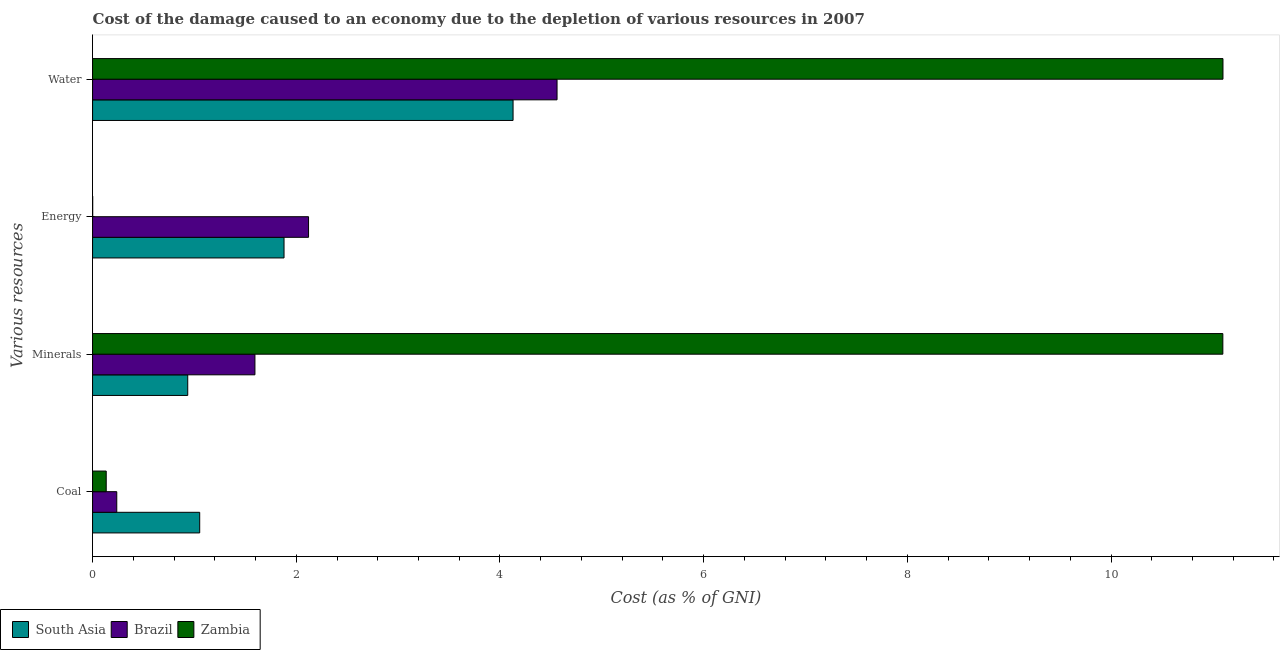What is the label of the 3rd group of bars from the top?
Keep it short and to the point. Minerals. What is the cost of damage due to depletion of coal in South Asia?
Offer a terse response. 1.05. Across all countries, what is the maximum cost of damage due to depletion of energy?
Provide a short and direct response. 2.12. Across all countries, what is the minimum cost of damage due to depletion of water?
Your answer should be very brief. 4.13. In which country was the cost of damage due to depletion of minerals maximum?
Give a very brief answer. Zambia. What is the total cost of damage due to depletion of water in the graph?
Offer a very short reply. 19.79. What is the difference between the cost of damage due to depletion of water in South Asia and that in Zambia?
Offer a terse response. -6.97. What is the difference between the cost of damage due to depletion of coal in Brazil and the cost of damage due to depletion of minerals in Zambia?
Keep it short and to the point. -10.86. What is the average cost of damage due to depletion of coal per country?
Ensure brevity in your answer.  0.47. What is the difference between the cost of damage due to depletion of energy and cost of damage due to depletion of coal in Zambia?
Provide a succinct answer. -0.13. What is the ratio of the cost of damage due to depletion of energy in Zambia to that in South Asia?
Give a very brief answer. 0. What is the difference between the highest and the second highest cost of damage due to depletion of energy?
Offer a very short reply. 0.24. What is the difference between the highest and the lowest cost of damage due to depletion of coal?
Make the answer very short. 0.92. Is it the case that in every country, the sum of the cost of damage due to depletion of water and cost of damage due to depletion of minerals is greater than the sum of cost of damage due to depletion of coal and cost of damage due to depletion of energy?
Offer a very short reply. Yes. What does the 1st bar from the top in Energy represents?
Your answer should be compact. Zambia. Is it the case that in every country, the sum of the cost of damage due to depletion of coal and cost of damage due to depletion of minerals is greater than the cost of damage due to depletion of energy?
Your answer should be very brief. No. What is the difference between two consecutive major ticks on the X-axis?
Provide a succinct answer. 2. Are the values on the major ticks of X-axis written in scientific E-notation?
Your response must be concise. No. Does the graph contain grids?
Make the answer very short. No. Where does the legend appear in the graph?
Ensure brevity in your answer.  Bottom left. How many legend labels are there?
Offer a terse response. 3. What is the title of the graph?
Offer a very short reply. Cost of the damage caused to an economy due to the depletion of various resources in 2007 . Does "Costa Rica" appear as one of the legend labels in the graph?
Make the answer very short. No. What is the label or title of the X-axis?
Keep it short and to the point. Cost (as % of GNI). What is the label or title of the Y-axis?
Offer a terse response. Various resources. What is the Cost (as % of GNI) in South Asia in Coal?
Make the answer very short. 1.05. What is the Cost (as % of GNI) of Brazil in Coal?
Ensure brevity in your answer.  0.24. What is the Cost (as % of GNI) of Zambia in Coal?
Your response must be concise. 0.13. What is the Cost (as % of GNI) of South Asia in Minerals?
Offer a very short reply. 0.93. What is the Cost (as % of GNI) of Brazil in Minerals?
Give a very brief answer. 1.59. What is the Cost (as % of GNI) of Zambia in Minerals?
Offer a very short reply. 11.1. What is the Cost (as % of GNI) of South Asia in Energy?
Ensure brevity in your answer.  1.88. What is the Cost (as % of GNI) in Brazil in Energy?
Offer a very short reply. 2.12. What is the Cost (as % of GNI) in Zambia in Energy?
Ensure brevity in your answer.  0. What is the Cost (as % of GNI) of South Asia in Water?
Offer a very short reply. 4.13. What is the Cost (as % of GNI) of Brazil in Water?
Your answer should be compact. 4.56. What is the Cost (as % of GNI) in Zambia in Water?
Your response must be concise. 11.1. Across all Various resources, what is the maximum Cost (as % of GNI) in South Asia?
Your answer should be compact. 4.13. Across all Various resources, what is the maximum Cost (as % of GNI) of Brazil?
Provide a short and direct response. 4.56. Across all Various resources, what is the maximum Cost (as % of GNI) of Zambia?
Ensure brevity in your answer.  11.1. Across all Various resources, what is the minimum Cost (as % of GNI) of South Asia?
Provide a succinct answer. 0.93. Across all Various resources, what is the minimum Cost (as % of GNI) of Brazil?
Keep it short and to the point. 0.24. Across all Various resources, what is the minimum Cost (as % of GNI) of Zambia?
Your answer should be compact. 0. What is the total Cost (as % of GNI) of South Asia in the graph?
Ensure brevity in your answer.  8. What is the total Cost (as % of GNI) in Brazil in the graph?
Offer a very short reply. 8.51. What is the total Cost (as % of GNI) in Zambia in the graph?
Make the answer very short. 22.33. What is the difference between the Cost (as % of GNI) of South Asia in Coal and that in Minerals?
Your answer should be compact. 0.12. What is the difference between the Cost (as % of GNI) of Brazil in Coal and that in Minerals?
Provide a short and direct response. -1.36. What is the difference between the Cost (as % of GNI) of Zambia in Coal and that in Minerals?
Your response must be concise. -10.96. What is the difference between the Cost (as % of GNI) of South Asia in Coal and that in Energy?
Provide a succinct answer. -0.83. What is the difference between the Cost (as % of GNI) in Brazil in Coal and that in Energy?
Your answer should be very brief. -1.88. What is the difference between the Cost (as % of GNI) of Zambia in Coal and that in Energy?
Make the answer very short. 0.13. What is the difference between the Cost (as % of GNI) in South Asia in Coal and that in Water?
Your answer should be compact. -3.08. What is the difference between the Cost (as % of GNI) in Brazil in Coal and that in Water?
Your response must be concise. -4.32. What is the difference between the Cost (as % of GNI) of Zambia in Coal and that in Water?
Make the answer very short. -10.97. What is the difference between the Cost (as % of GNI) in South Asia in Minerals and that in Energy?
Provide a succinct answer. -0.95. What is the difference between the Cost (as % of GNI) of Brazil in Minerals and that in Energy?
Your answer should be very brief. -0.53. What is the difference between the Cost (as % of GNI) in Zambia in Minerals and that in Energy?
Your answer should be compact. 11.1. What is the difference between the Cost (as % of GNI) of South Asia in Minerals and that in Water?
Your answer should be compact. -3.19. What is the difference between the Cost (as % of GNI) in Brazil in Minerals and that in Water?
Keep it short and to the point. -2.97. What is the difference between the Cost (as % of GNI) of Zambia in Minerals and that in Water?
Ensure brevity in your answer.  -0. What is the difference between the Cost (as % of GNI) in South Asia in Energy and that in Water?
Give a very brief answer. -2.25. What is the difference between the Cost (as % of GNI) of Brazil in Energy and that in Water?
Make the answer very short. -2.44. What is the difference between the Cost (as % of GNI) of Zambia in Energy and that in Water?
Your response must be concise. -11.1. What is the difference between the Cost (as % of GNI) of South Asia in Coal and the Cost (as % of GNI) of Brazil in Minerals?
Your answer should be very brief. -0.54. What is the difference between the Cost (as % of GNI) of South Asia in Coal and the Cost (as % of GNI) of Zambia in Minerals?
Your response must be concise. -10.05. What is the difference between the Cost (as % of GNI) of Brazil in Coal and the Cost (as % of GNI) of Zambia in Minerals?
Provide a short and direct response. -10.86. What is the difference between the Cost (as % of GNI) in South Asia in Coal and the Cost (as % of GNI) in Brazil in Energy?
Offer a terse response. -1.07. What is the difference between the Cost (as % of GNI) of South Asia in Coal and the Cost (as % of GNI) of Zambia in Energy?
Your response must be concise. 1.05. What is the difference between the Cost (as % of GNI) of Brazil in Coal and the Cost (as % of GNI) of Zambia in Energy?
Provide a succinct answer. 0.24. What is the difference between the Cost (as % of GNI) in South Asia in Coal and the Cost (as % of GNI) in Brazil in Water?
Your response must be concise. -3.51. What is the difference between the Cost (as % of GNI) in South Asia in Coal and the Cost (as % of GNI) in Zambia in Water?
Give a very brief answer. -10.05. What is the difference between the Cost (as % of GNI) in Brazil in Coal and the Cost (as % of GNI) in Zambia in Water?
Offer a terse response. -10.86. What is the difference between the Cost (as % of GNI) of South Asia in Minerals and the Cost (as % of GNI) of Brazil in Energy?
Offer a terse response. -1.19. What is the difference between the Cost (as % of GNI) of South Asia in Minerals and the Cost (as % of GNI) of Zambia in Energy?
Provide a short and direct response. 0.93. What is the difference between the Cost (as % of GNI) of Brazil in Minerals and the Cost (as % of GNI) of Zambia in Energy?
Keep it short and to the point. 1.59. What is the difference between the Cost (as % of GNI) of South Asia in Minerals and the Cost (as % of GNI) of Brazil in Water?
Keep it short and to the point. -3.63. What is the difference between the Cost (as % of GNI) of South Asia in Minerals and the Cost (as % of GNI) of Zambia in Water?
Provide a short and direct response. -10.16. What is the difference between the Cost (as % of GNI) of Brazil in Minerals and the Cost (as % of GNI) of Zambia in Water?
Your answer should be very brief. -9.5. What is the difference between the Cost (as % of GNI) in South Asia in Energy and the Cost (as % of GNI) in Brazil in Water?
Make the answer very short. -2.68. What is the difference between the Cost (as % of GNI) of South Asia in Energy and the Cost (as % of GNI) of Zambia in Water?
Offer a very short reply. -9.22. What is the difference between the Cost (as % of GNI) of Brazil in Energy and the Cost (as % of GNI) of Zambia in Water?
Keep it short and to the point. -8.98. What is the average Cost (as % of GNI) of South Asia per Various resources?
Give a very brief answer. 2. What is the average Cost (as % of GNI) of Brazil per Various resources?
Your answer should be very brief. 2.13. What is the average Cost (as % of GNI) in Zambia per Various resources?
Give a very brief answer. 5.58. What is the difference between the Cost (as % of GNI) of South Asia and Cost (as % of GNI) of Brazil in Coal?
Your answer should be very brief. 0.81. What is the difference between the Cost (as % of GNI) of South Asia and Cost (as % of GNI) of Zambia in Coal?
Offer a very short reply. 0.92. What is the difference between the Cost (as % of GNI) of Brazil and Cost (as % of GNI) of Zambia in Coal?
Give a very brief answer. 0.1. What is the difference between the Cost (as % of GNI) in South Asia and Cost (as % of GNI) in Brazil in Minerals?
Offer a very short reply. -0.66. What is the difference between the Cost (as % of GNI) of South Asia and Cost (as % of GNI) of Zambia in Minerals?
Your answer should be compact. -10.16. What is the difference between the Cost (as % of GNI) in Brazil and Cost (as % of GNI) in Zambia in Minerals?
Your answer should be very brief. -9.5. What is the difference between the Cost (as % of GNI) in South Asia and Cost (as % of GNI) in Brazil in Energy?
Provide a short and direct response. -0.24. What is the difference between the Cost (as % of GNI) in South Asia and Cost (as % of GNI) in Zambia in Energy?
Provide a short and direct response. 1.88. What is the difference between the Cost (as % of GNI) of Brazil and Cost (as % of GNI) of Zambia in Energy?
Offer a terse response. 2.12. What is the difference between the Cost (as % of GNI) of South Asia and Cost (as % of GNI) of Brazil in Water?
Your answer should be very brief. -0.43. What is the difference between the Cost (as % of GNI) of South Asia and Cost (as % of GNI) of Zambia in Water?
Provide a succinct answer. -6.97. What is the difference between the Cost (as % of GNI) in Brazil and Cost (as % of GNI) in Zambia in Water?
Your answer should be very brief. -6.54. What is the ratio of the Cost (as % of GNI) in South Asia in Coal to that in Minerals?
Ensure brevity in your answer.  1.13. What is the ratio of the Cost (as % of GNI) in Brazil in Coal to that in Minerals?
Offer a terse response. 0.15. What is the ratio of the Cost (as % of GNI) of Zambia in Coal to that in Minerals?
Offer a very short reply. 0.01. What is the ratio of the Cost (as % of GNI) of South Asia in Coal to that in Energy?
Provide a succinct answer. 0.56. What is the ratio of the Cost (as % of GNI) in Brazil in Coal to that in Energy?
Your response must be concise. 0.11. What is the ratio of the Cost (as % of GNI) in Zambia in Coal to that in Energy?
Give a very brief answer. 104.14. What is the ratio of the Cost (as % of GNI) in South Asia in Coal to that in Water?
Your answer should be very brief. 0.25. What is the ratio of the Cost (as % of GNI) of Brazil in Coal to that in Water?
Make the answer very short. 0.05. What is the ratio of the Cost (as % of GNI) of Zambia in Coal to that in Water?
Ensure brevity in your answer.  0.01. What is the ratio of the Cost (as % of GNI) of South Asia in Minerals to that in Energy?
Keep it short and to the point. 0.5. What is the ratio of the Cost (as % of GNI) in Brazil in Minerals to that in Energy?
Ensure brevity in your answer.  0.75. What is the ratio of the Cost (as % of GNI) in Zambia in Minerals to that in Energy?
Your answer should be very brief. 8625.85. What is the ratio of the Cost (as % of GNI) of South Asia in Minerals to that in Water?
Your answer should be very brief. 0.23. What is the ratio of the Cost (as % of GNI) of Brazil in Minerals to that in Water?
Ensure brevity in your answer.  0.35. What is the ratio of the Cost (as % of GNI) in Zambia in Minerals to that in Water?
Give a very brief answer. 1. What is the ratio of the Cost (as % of GNI) in South Asia in Energy to that in Water?
Your response must be concise. 0.46. What is the ratio of the Cost (as % of GNI) in Brazil in Energy to that in Water?
Provide a short and direct response. 0.47. What is the difference between the highest and the second highest Cost (as % of GNI) of South Asia?
Ensure brevity in your answer.  2.25. What is the difference between the highest and the second highest Cost (as % of GNI) of Brazil?
Your answer should be compact. 2.44. What is the difference between the highest and the second highest Cost (as % of GNI) of Zambia?
Keep it short and to the point. 0. What is the difference between the highest and the lowest Cost (as % of GNI) in South Asia?
Give a very brief answer. 3.19. What is the difference between the highest and the lowest Cost (as % of GNI) of Brazil?
Ensure brevity in your answer.  4.32. What is the difference between the highest and the lowest Cost (as % of GNI) of Zambia?
Provide a succinct answer. 11.1. 